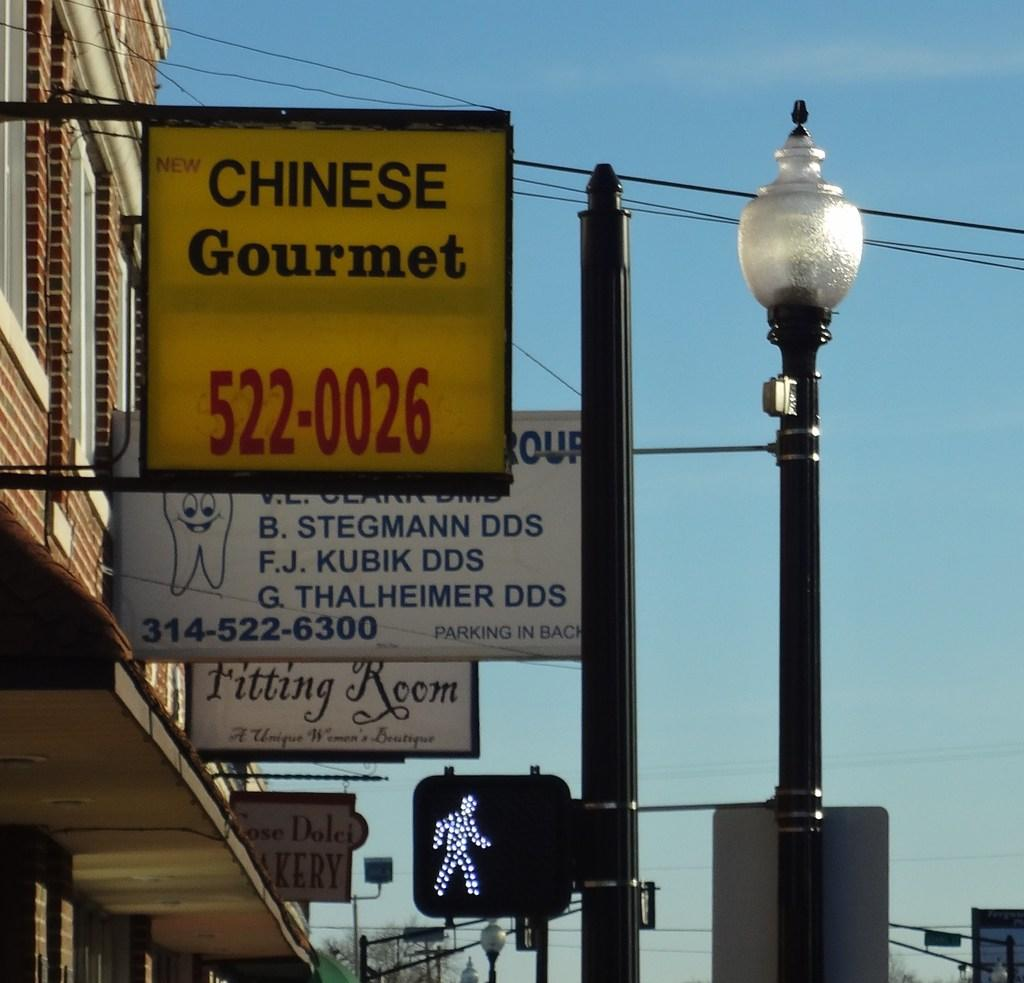What type of structures can be seen in the image? There are buildings in the image. What else is present in the image besides the buildings? There are boards attached to poles and a signal light in the image. Can you see any eggnog being served in the image? There is no eggnog present in the image. Is there a goat visible in the image? There is no goat present in the image. 